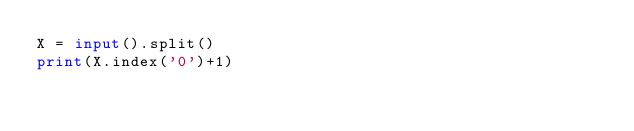<code> <loc_0><loc_0><loc_500><loc_500><_Python_>X = input().split()
print(X.index('0')+1)</code> 